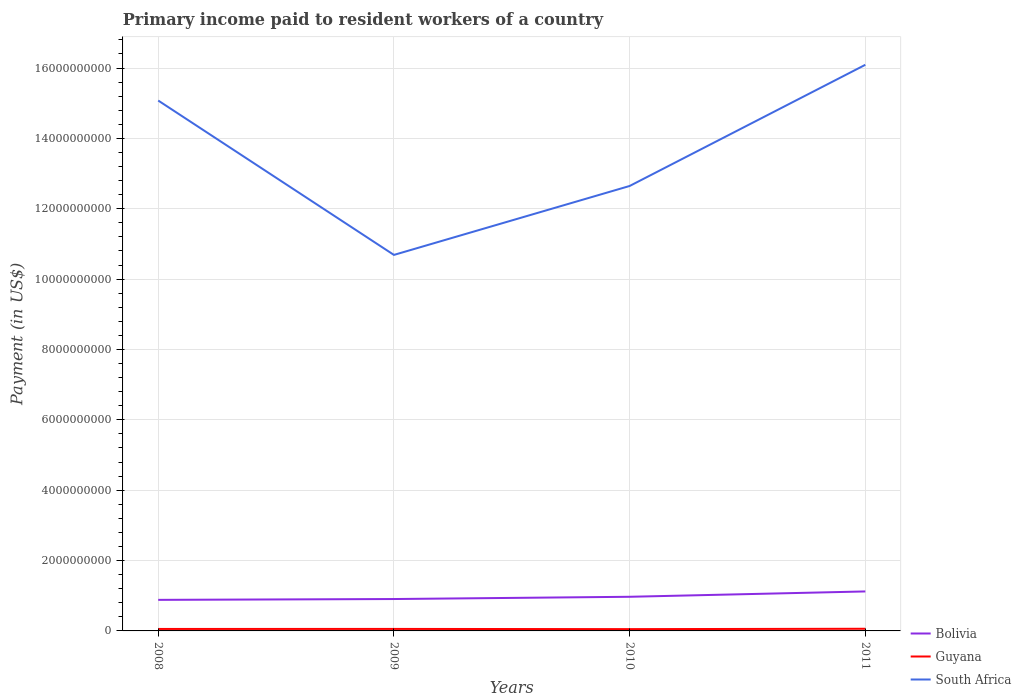Is the number of lines equal to the number of legend labels?
Offer a very short reply. Yes. Across all years, what is the maximum amount paid to workers in South Africa?
Provide a succinct answer. 1.07e+1. What is the total amount paid to workers in South Africa in the graph?
Provide a short and direct response. -5.40e+09. What is the difference between the highest and the second highest amount paid to workers in South Africa?
Offer a terse response. 5.40e+09. What is the difference between the highest and the lowest amount paid to workers in South Africa?
Give a very brief answer. 2. Is the amount paid to workers in Bolivia strictly greater than the amount paid to workers in Guyana over the years?
Your answer should be compact. No. How many lines are there?
Give a very brief answer. 3. How many years are there in the graph?
Offer a very short reply. 4. Are the values on the major ticks of Y-axis written in scientific E-notation?
Give a very brief answer. No. Does the graph contain any zero values?
Your answer should be very brief. No. What is the title of the graph?
Give a very brief answer. Primary income paid to resident workers of a country. What is the label or title of the Y-axis?
Your response must be concise. Payment (in US$). What is the Payment (in US$) in Bolivia in 2008?
Make the answer very short. 8.83e+08. What is the Payment (in US$) of Guyana in 2008?
Provide a succinct answer. 5.61e+07. What is the Payment (in US$) of South Africa in 2008?
Offer a very short reply. 1.51e+1. What is the Payment (in US$) in Bolivia in 2009?
Keep it short and to the point. 9.06e+08. What is the Payment (in US$) of Guyana in 2009?
Offer a very short reply. 5.67e+07. What is the Payment (in US$) of South Africa in 2009?
Ensure brevity in your answer.  1.07e+1. What is the Payment (in US$) of Bolivia in 2010?
Make the answer very short. 9.71e+08. What is the Payment (in US$) of Guyana in 2010?
Your answer should be very brief. 5.12e+07. What is the Payment (in US$) of South Africa in 2010?
Your answer should be very brief. 1.26e+1. What is the Payment (in US$) of Bolivia in 2011?
Provide a short and direct response. 1.12e+09. What is the Payment (in US$) in Guyana in 2011?
Offer a very short reply. 6.12e+07. What is the Payment (in US$) of South Africa in 2011?
Give a very brief answer. 1.61e+1. Across all years, what is the maximum Payment (in US$) of Bolivia?
Ensure brevity in your answer.  1.12e+09. Across all years, what is the maximum Payment (in US$) of Guyana?
Provide a short and direct response. 6.12e+07. Across all years, what is the maximum Payment (in US$) in South Africa?
Make the answer very short. 1.61e+1. Across all years, what is the minimum Payment (in US$) in Bolivia?
Offer a very short reply. 8.83e+08. Across all years, what is the minimum Payment (in US$) in Guyana?
Provide a succinct answer. 5.12e+07. Across all years, what is the minimum Payment (in US$) in South Africa?
Ensure brevity in your answer.  1.07e+1. What is the total Payment (in US$) of Bolivia in the graph?
Ensure brevity in your answer.  3.88e+09. What is the total Payment (in US$) of Guyana in the graph?
Your answer should be very brief. 2.25e+08. What is the total Payment (in US$) of South Africa in the graph?
Your answer should be compact. 5.45e+1. What is the difference between the Payment (in US$) in Bolivia in 2008 and that in 2009?
Your answer should be compact. -2.36e+07. What is the difference between the Payment (in US$) of Guyana in 2008 and that in 2009?
Provide a short and direct response. -6.24e+05. What is the difference between the Payment (in US$) of South Africa in 2008 and that in 2009?
Provide a succinct answer. 4.39e+09. What is the difference between the Payment (in US$) of Bolivia in 2008 and that in 2010?
Provide a succinct answer. -8.78e+07. What is the difference between the Payment (in US$) in Guyana in 2008 and that in 2010?
Offer a terse response. 4.84e+06. What is the difference between the Payment (in US$) of South Africa in 2008 and that in 2010?
Offer a very short reply. 2.43e+09. What is the difference between the Payment (in US$) of Bolivia in 2008 and that in 2011?
Your answer should be very brief. -2.40e+08. What is the difference between the Payment (in US$) of Guyana in 2008 and that in 2011?
Ensure brevity in your answer.  -5.16e+06. What is the difference between the Payment (in US$) in South Africa in 2008 and that in 2011?
Offer a terse response. -1.02e+09. What is the difference between the Payment (in US$) of Bolivia in 2009 and that in 2010?
Provide a succinct answer. -6.42e+07. What is the difference between the Payment (in US$) of Guyana in 2009 and that in 2010?
Make the answer very short. 5.47e+06. What is the difference between the Payment (in US$) of South Africa in 2009 and that in 2010?
Offer a terse response. -1.96e+09. What is the difference between the Payment (in US$) of Bolivia in 2009 and that in 2011?
Provide a short and direct response. -2.16e+08. What is the difference between the Payment (in US$) of Guyana in 2009 and that in 2011?
Your response must be concise. -4.54e+06. What is the difference between the Payment (in US$) of South Africa in 2009 and that in 2011?
Ensure brevity in your answer.  -5.40e+09. What is the difference between the Payment (in US$) in Bolivia in 2010 and that in 2011?
Offer a very short reply. -1.52e+08. What is the difference between the Payment (in US$) in Guyana in 2010 and that in 2011?
Offer a terse response. -1.00e+07. What is the difference between the Payment (in US$) in South Africa in 2010 and that in 2011?
Provide a short and direct response. -3.44e+09. What is the difference between the Payment (in US$) of Bolivia in 2008 and the Payment (in US$) of Guyana in 2009?
Your response must be concise. 8.26e+08. What is the difference between the Payment (in US$) of Bolivia in 2008 and the Payment (in US$) of South Africa in 2009?
Offer a terse response. -9.81e+09. What is the difference between the Payment (in US$) of Guyana in 2008 and the Payment (in US$) of South Africa in 2009?
Your answer should be compact. -1.06e+1. What is the difference between the Payment (in US$) in Bolivia in 2008 and the Payment (in US$) in Guyana in 2010?
Make the answer very short. 8.32e+08. What is the difference between the Payment (in US$) of Bolivia in 2008 and the Payment (in US$) of South Africa in 2010?
Offer a very short reply. -1.18e+1. What is the difference between the Payment (in US$) of Guyana in 2008 and the Payment (in US$) of South Africa in 2010?
Ensure brevity in your answer.  -1.26e+1. What is the difference between the Payment (in US$) in Bolivia in 2008 and the Payment (in US$) in Guyana in 2011?
Keep it short and to the point. 8.22e+08. What is the difference between the Payment (in US$) in Bolivia in 2008 and the Payment (in US$) in South Africa in 2011?
Ensure brevity in your answer.  -1.52e+1. What is the difference between the Payment (in US$) of Guyana in 2008 and the Payment (in US$) of South Africa in 2011?
Your response must be concise. -1.60e+1. What is the difference between the Payment (in US$) in Bolivia in 2009 and the Payment (in US$) in Guyana in 2010?
Keep it short and to the point. 8.55e+08. What is the difference between the Payment (in US$) in Bolivia in 2009 and the Payment (in US$) in South Africa in 2010?
Ensure brevity in your answer.  -1.17e+1. What is the difference between the Payment (in US$) in Guyana in 2009 and the Payment (in US$) in South Africa in 2010?
Your answer should be compact. -1.26e+1. What is the difference between the Payment (in US$) of Bolivia in 2009 and the Payment (in US$) of Guyana in 2011?
Provide a short and direct response. 8.45e+08. What is the difference between the Payment (in US$) in Bolivia in 2009 and the Payment (in US$) in South Africa in 2011?
Ensure brevity in your answer.  -1.52e+1. What is the difference between the Payment (in US$) in Guyana in 2009 and the Payment (in US$) in South Africa in 2011?
Your answer should be compact. -1.60e+1. What is the difference between the Payment (in US$) of Bolivia in 2010 and the Payment (in US$) of Guyana in 2011?
Ensure brevity in your answer.  9.09e+08. What is the difference between the Payment (in US$) of Bolivia in 2010 and the Payment (in US$) of South Africa in 2011?
Ensure brevity in your answer.  -1.51e+1. What is the difference between the Payment (in US$) in Guyana in 2010 and the Payment (in US$) in South Africa in 2011?
Your response must be concise. -1.60e+1. What is the average Payment (in US$) of Bolivia per year?
Your answer should be compact. 9.71e+08. What is the average Payment (in US$) of Guyana per year?
Ensure brevity in your answer.  5.63e+07. What is the average Payment (in US$) of South Africa per year?
Give a very brief answer. 1.36e+1. In the year 2008, what is the difference between the Payment (in US$) of Bolivia and Payment (in US$) of Guyana?
Provide a short and direct response. 8.27e+08. In the year 2008, what is the difference between the Payment (in US$) of Bolivia and Payment (in US$) of South Africa?
Provide a succinct answer. -1.42e+1. In the year 2008, what is the difference between the Payment (in US$) in Guyana and Payment (in US$) in South Africa?
Offer a very short reply. -1.50e+1. In the year 2009, what is the difference between the Payment (in US$) in Bolivia and Payment (in US$) in Guyana?
Ensure brevity in your answer.  8.50e+08. In the year 2009, what is the difference between the Payment (in US$) in Bolivia and Payment (in US$) in South Africa?
Your answer should be compact. -9.78e+09. In the year 2009, what is the difference between the Payment (in US$) in Guyana and Payment (in US$) in South Africa?
Your response must be concise. -1.06e+1. In the year 2010, what is the difference between the Payment (in US$) in Bolivia and Payment (in US$) in Guyana?
Offer a terse response. 9.19e+08. In the year 2010, what is the difference between the Payment (in US$) in Bolivia and Payment (in US$) in South Africa?
Offer a terse response. -1.17e+1. In the year 2010, what is the difference between the Payment (in US$) of Guyana and Payment (in US$) of South Africa?
Your answer should be compact. -1.26e+1. In the year 2011, what is the difference between the Payment (in US$) of Bolivia and Payment (in US$) of Guyana?
Provide a succinct answer. 1.06e+09. In the year 2011, what is the difference between the Payment (in US$) in Bolivia and Payment (in US$) in South Africa?
Your answer should be very brief. -1.50e+1. In the year 2011, what is the difference between the Payment (in US$) in Guyana and Payment (in US$) in South Africa?
Offer a terse response. -1.60e+1. What is the ratio of the Payment (in US$) of Bolivia in 2008 to that in 2009?
Your answer should be compact. 0.97. What is the ratio of the Payment (in US$) of Guyana in 2008 to that in 2009?
Make the answer very short. 0.99. What is the ratio of the Payment (in US$) of South Africa in 2008 to that in 2009?
Your answer should be compact. 1.41. What is the ratio of the Payment (in US$) in Bolivia in 2008 to that in 2010?
Ensure brevity in your answer.  0.91. What is the ratio of the Payment (in US$) of Guyana in 2008 to that in 2010?
Make the answer very short. 1.09. What is the ratio of the Payment (in US$) of South Africa in 2008 to that in 2010?
Ensure brevity in your answer.  1.19. What is the ratio of the Payment (in US$) of Bolivia in 2008 to that in 2011?
Offer a very short reply. 0.79. What is the ratio of the Payment (in US$) in Guyana in 2008 to that in 2011?
Give a very brief answer. 0.92. What is the ratio of the Payment (in US$) of South Africa in 2008 to that in 2011?
Give a very brief answer. 0.94. What is the ratio of the Payment (in US$) in Bolivia in 2009 to that in 2010?
Give a very brief answer. 0.93. What is the ratio of the Payment (in US$) of Guyana in 2009 to that in 2010?
Your answer should be compact. 1.11. What is the ratio of the Payment (in US$) in South Africa in 2009 to that in 2010?
Provide a succinct answer. 0.85. What is the ratio of the Payment (in US$) of Bolivia in 2009 to that in 2011?
Keep it short and to the point. 0.81. What is the ratio of the Payment (in US$) in Guyana in 2009 to that in 2011?
Make the answer very short. 0.93. What is the ratio of the Payment (in US$) of South Africa in 2009 to that in 2011?
Your answer should be very brief. 0.66. What is the ratio of the Payment (in US$) in Bolivia in 2010 to that in 2011?
Your response must be concise. 0.86. What is the ratio of the Payment (in US$) in Guyana in 2010 to that in 2011?
Your answer should be compact. 0.84. What is the ratio of the Payment (in US$) of South Africa in 2010 to that in 2011?
Give a very brief answer. 0.79. What is the difference between the highest and the second highest Payment (in US$) of Bolivia?
Make the answer very short. 1.52e+08. What is the difference between the highest and the second highest Payment (in US$) of Guyana?
Ensure brevity in your answer.  4.54e+06. What is the difference between the highest and the second highest Payment (in US$) of South Africa?
Make the answer very short. 1.02e+09. What is the difference between the highest and the lowest Payment (in US$) in Bolivia?
Your answer should be compact. 2.40e+08. What is the difference between the highest and the lowest Payment (in US$) in Guyana?
Make the answer very short. 1.00e+07. What is the difference between the highest and the lowest Payment (in US$) in South Africa?
Your response must be concise. 5.40e+09. 